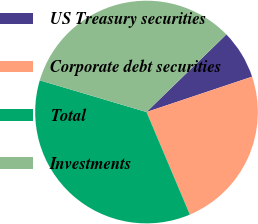Convert chart to OTSL. <chart><loc_0><loc_0><loc_500><loc_500><pie_chart><fcel>US Treasury securities<fcel>Corporate debt securities<fcel>Total<fcel>Investments<nl><fcel>7.13%<fcel>23.78%<fcel>35.96%<fcel>33.13%<nl></chart> 